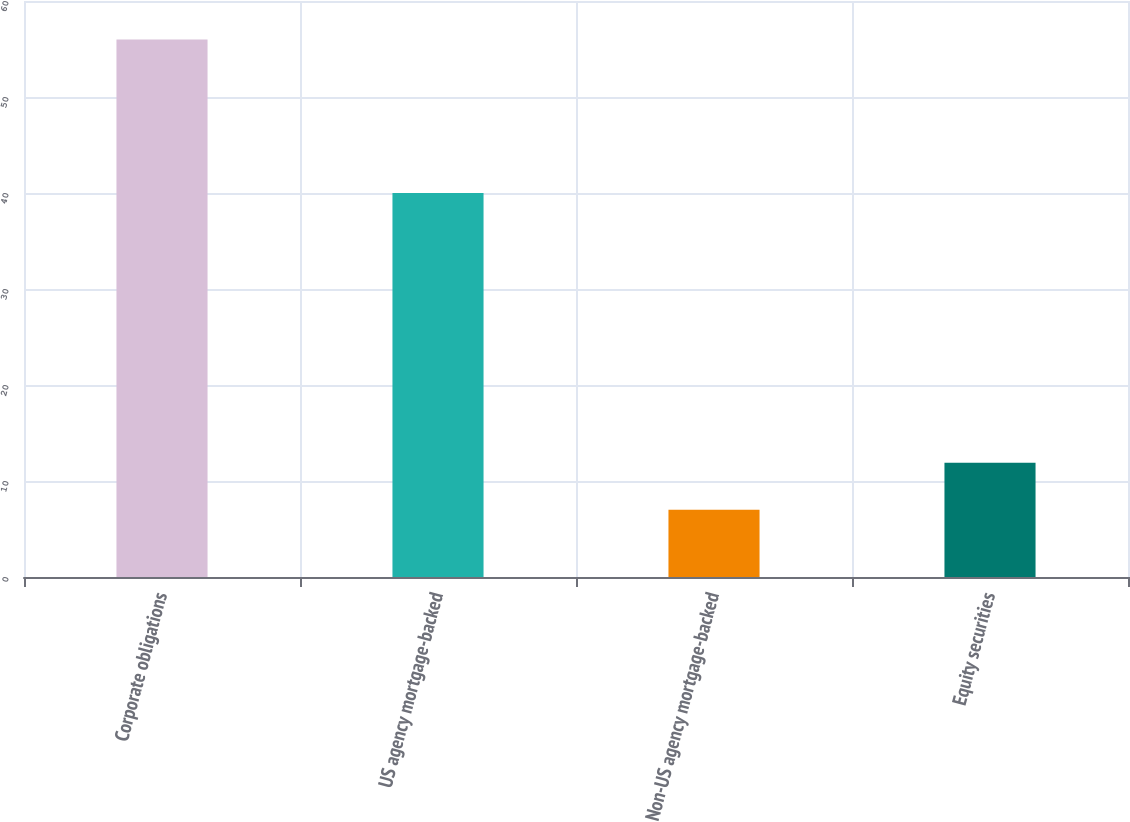Convert chart to OTSL. <chart><loc_0><loc_0><loc_500><loc_500><bar_chart><fcel>Corporate obligations<fcel>US agency mortgage-backed<fcel>Non-US agency mortgage-backed<fcel>Equity securities<nl><fcel>56<fcel>40<fcel>7<fcel>11.9<nl></chart> 